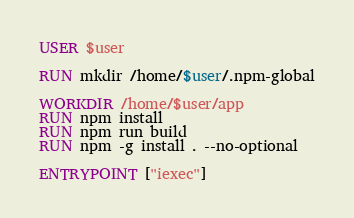<code> <loc_0><loc_0><loc_500><loc_500><_Dockerfile_>USER $user

RUN mkdir /home/$user/.npm-global

WORKDIR /home/$user/app
RUN npm install
RUN npm run build
RUN npm -g install . --no-optional

ENTRYPOINT ["iexec"]
</code> 